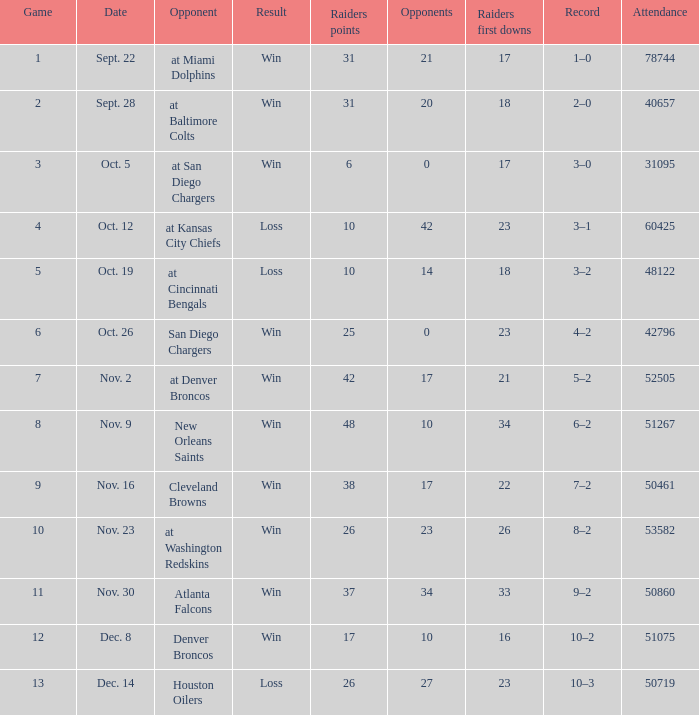How many opponents played 1 game with a result win? 21.0. 